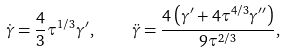Convert formula to latex. <formula><loc_0><loc_0><loc_500><loc_500>\dot { \gamma } = \frac { 4 } { 3 } \tau ^ { 1 / 3 } \gamma ^ { \prime } , \quad \ddot { \gamma } = \frac { 4 \left ( \gamma ^ { \prime } + 4 \tau ^ { 4 / 3 } \gamma ^ { \prime \prime } \right ) } { 9 \tau ^ { 2 / 3 } } ,</formula> 